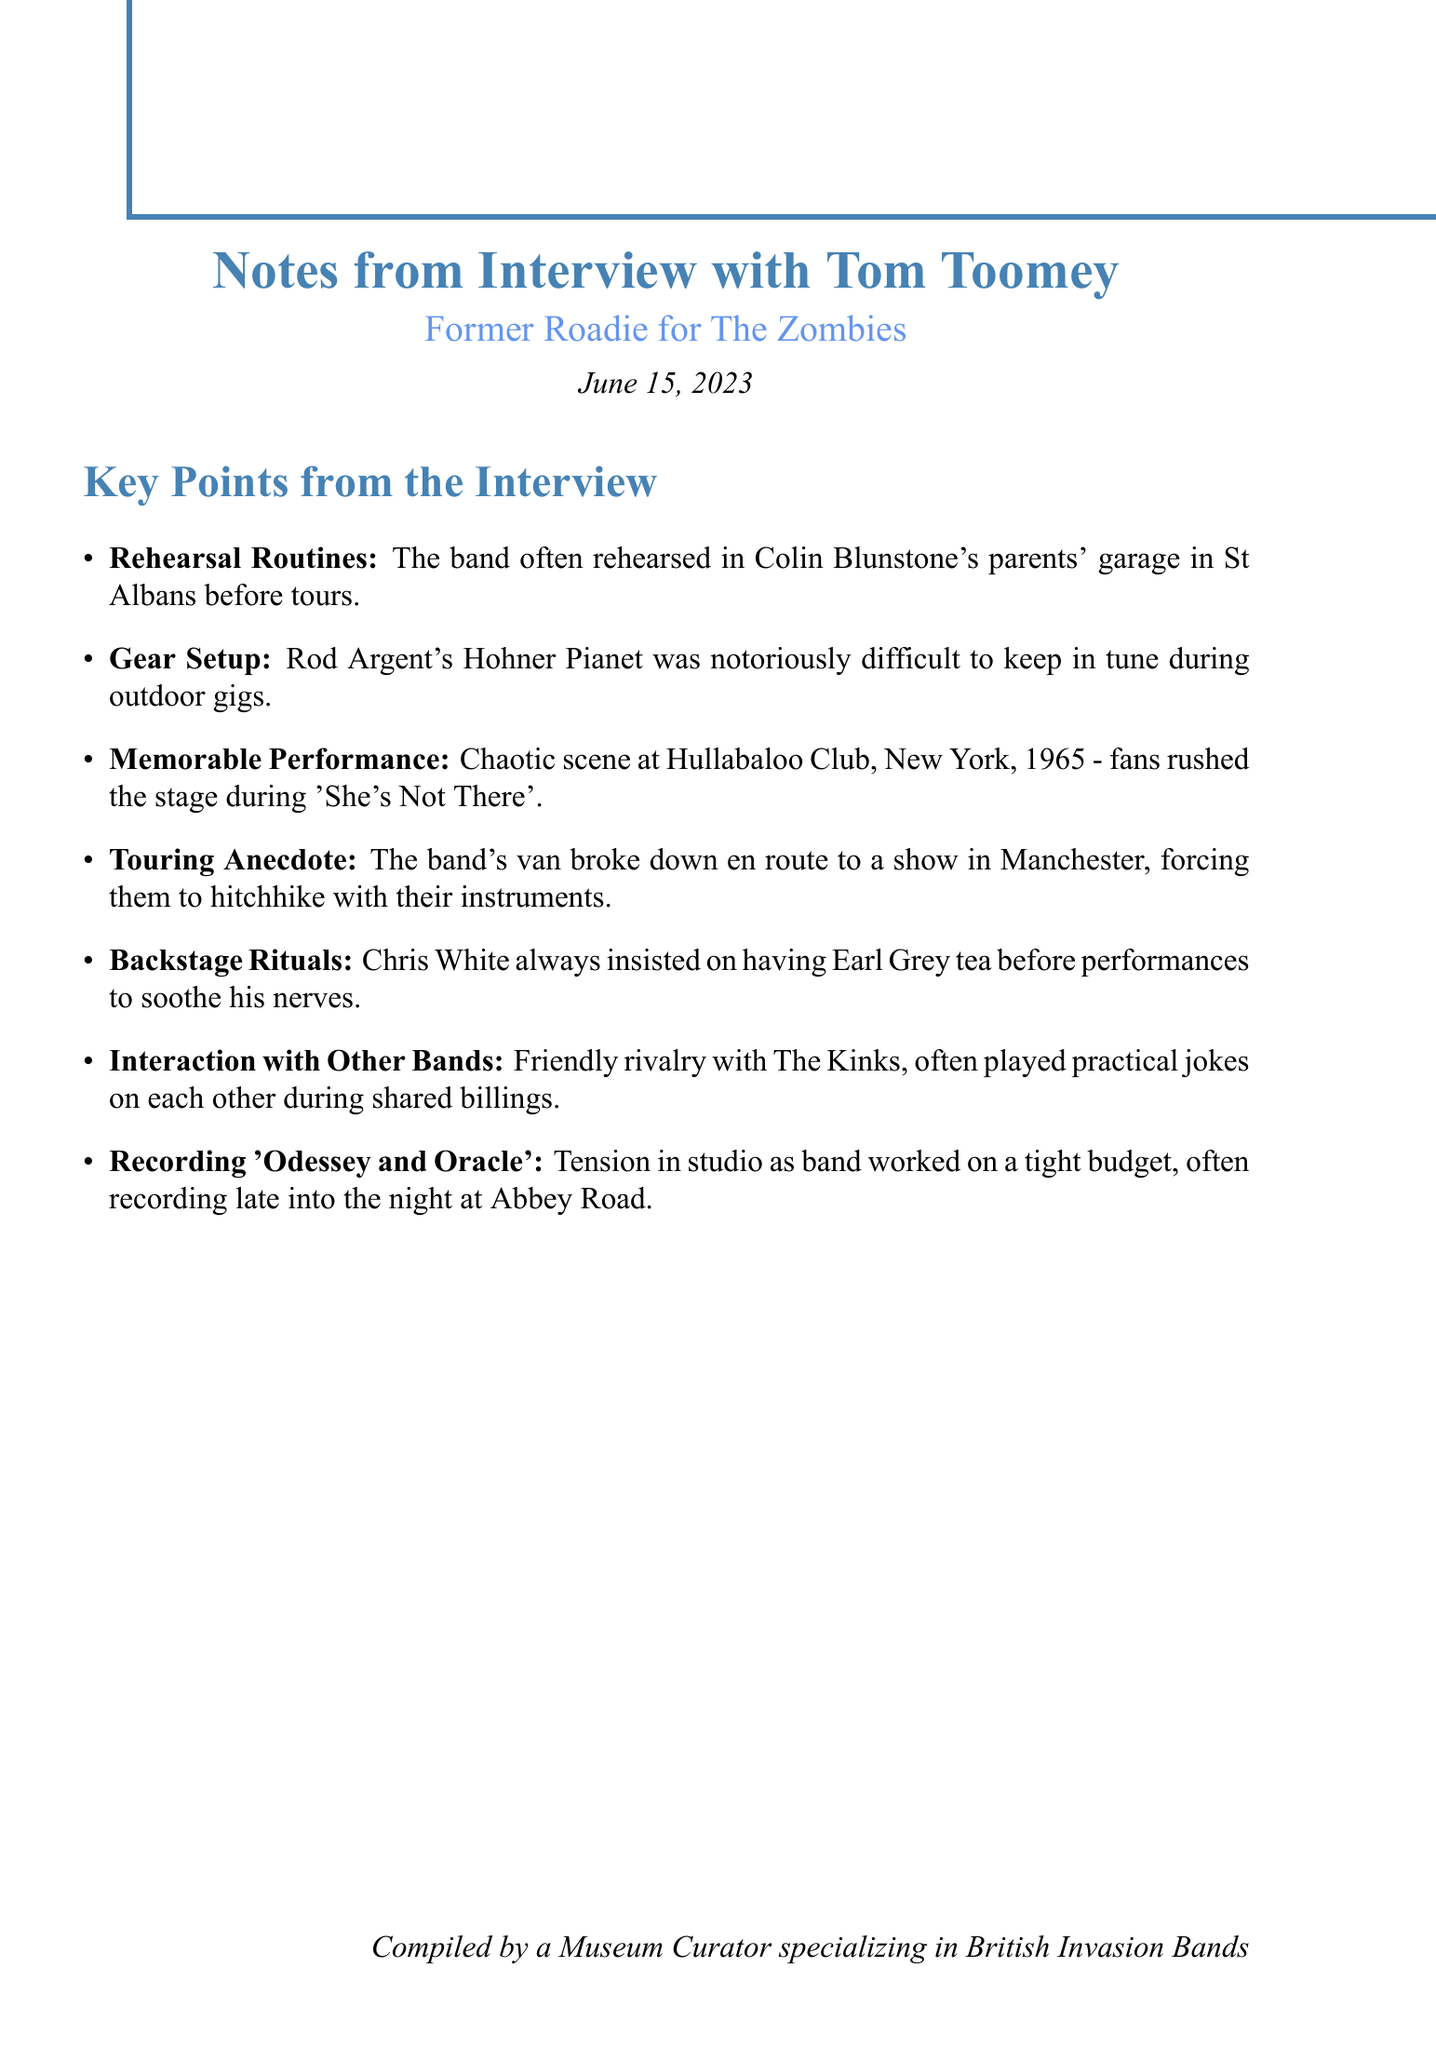What was the rehearsal location for The Zombies? The document states that the band often rehearsed in Colin Blunstone's parents' garage in St Albans before tours.
Answer: Colin Blunstone's parents' garage What gear was difficult to tune during outdoor gigs? The document mentions that Rod Argent's Hohner Pianet was notoriously difficult to keep in tune during outdoor gigs.
Answer: Hohner Pianet Which performance was described as chaotic? The document specifies that the chaotic scene occurred at the Hullabaloo Club in New York, 1965 during 'She's Not There'.
Answer: Hullabaloo Club How did the band travel after their van broke down? The interview notes indicate that they had to hitchhike with their instruments to a show in Manchester.
Answer: Hitchhike What type of tea did Chris White insist on having before performances? According to the document, Chris White always insisted on having Earl Grey tea before performances.
Answer: Earl Grey Which band did The Zombies have a friendly rivalry with? The document notes that The Zombies had a friendly rivalry with The Kinks.
Answer: The Kinks Where did the recording of 'Odessey and Oracle' take place? The document states that the band often recorded late into the night at Abbey Road.
Answer: Abbey Road On what date was the interview conducted? The document clearly indicates that the interview took place on June 15, 2023.
Answer: June 15, 2023 How did the band feel during the recording sessions? The document mentions that there was tension in the studio as the band worked on a tight budget.
Answer: Tension 